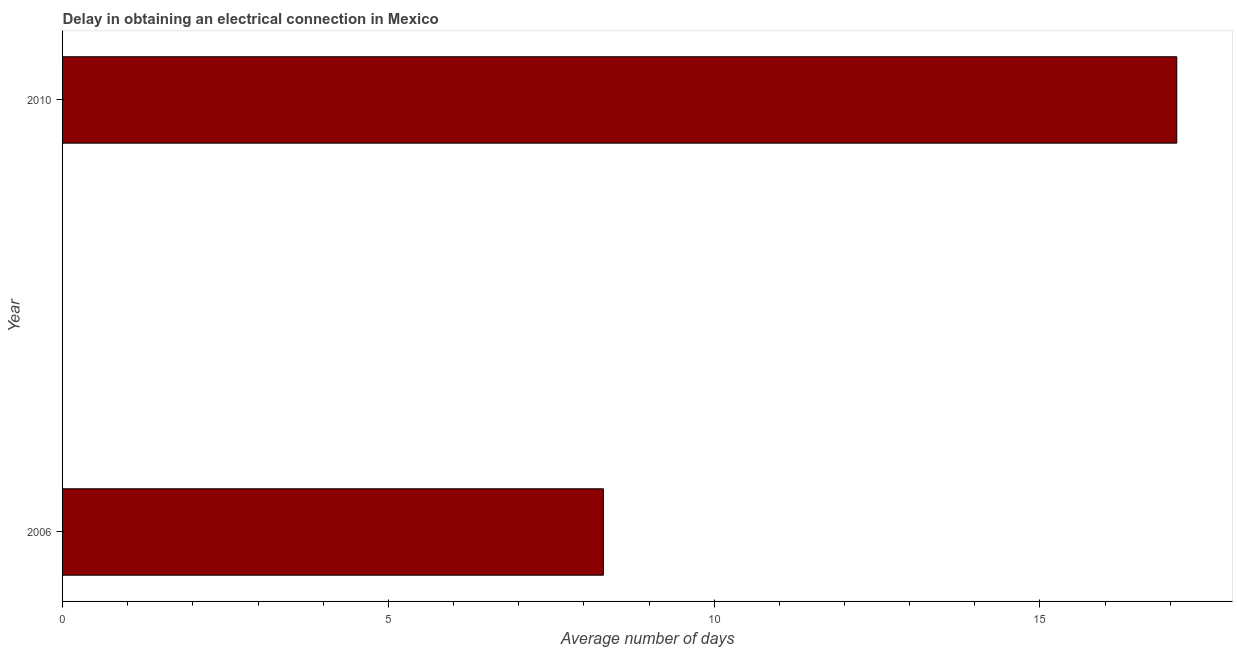Does the graph contain grids?
Make the answer very short. No. What is the title of the graph?
Give a very brief answer. Delay in obtaining an electrical connection in Mexico. What is the label or title of the X-axis?
Offer a terse response. Average number of days. What is the label or title of the Y-axis?
Provide a succinct answer. Year. In which year was the dalay in electrical connection maximum?
Your response must be concise. 2010. In which year was the dalay in electrical connection minimum?
Offer a very short reply. 2006. What is the sum of the dalay in electrical connection?
Your answer should be very brief. 25.4. What is the median dalay in electrical connection?
Offer a very short reply. 12.7. Do a majority of the years between 2006 and 2010 (inclusive) have dalay in electrical connection greater than 7 days?
Provide a succinct answer. Yes. What is the ratio of the dalay in electrical connection in 2006 to that in 2010?
Give a very brief answer. 0.48. Is the dalay in electrical connection in 2006 less than that in 2010?
Your answer should be very brief. Yes. In how many years, is the dalay in electrical connection greater than the average dalay in electrical connection taken over all years?
Your answer should be compact. 1. Are all the bars in the graph horizontal?
Your response must be concise. Yes. Are the values on the major ticks of X-axis written in scientific E-notation?
Offer a very short reply. No. What is the Average number of days of 2006?
Your answer should be compact. 8.3. What is the ratio of the Average number of days in 2006 to that in 2010?
Your answer should be compact. 0.48. 